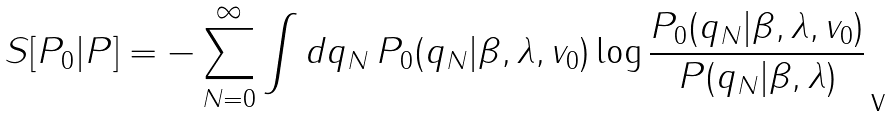Convert formula to latex. <formula><loc_0><loc_0><loc_500><loc_500>S [ P _ { 0 } | P ] = - \sum _ { N = 0 } ^ { \infty } \int d q _ { N } \, P _ { 0 } ( q _ { N } | \beta , \lambda , v _ { 0 } ) \log \frac { P _ { 0 } ( q _ { N } | \beta , \lambda , v _ { 0 } ) } { P ( q _ { N } | \beta , \lambda ) }</formula> 